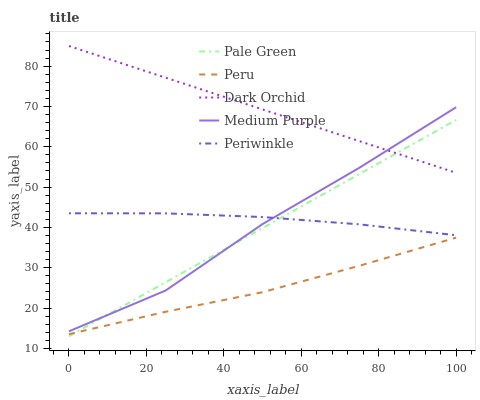Does Peru have the minimum area under the curve?
Answer yes or no. Yes. Does Dark Orchid have the maximum area under the curve?
Answer yes or no. Yes. Does Pale Green have the minimum area under the curve?
Answer yes or no. No. Does Pale Green have the maximum area under the curve?
Answer yes or no. No. Is Pale Green the smoothest?
Answer yes or no. Yes. Is Medium Purple the roughest?
Answer yes or no. Yes. Is Periwinkle the smoothest?
Answer yes or no. No. Is Periwinkle the roughest?
Answer yes or no. No. Does Periwinkle have the lowest value?
Answer yes or no. No. Does Dark Orchid have the highest value?
Answer yes or no. Yes. Does Pale Green have the highest value?
Answer yes or no. No. Is Peru less than Dark Orchid?
Answer yes or no. Yes. Is Periwinkle greater than Peru?
Answer yes or no. Yes. Does Peru intersect Dark Orchid?
Answer yes or no. No. 